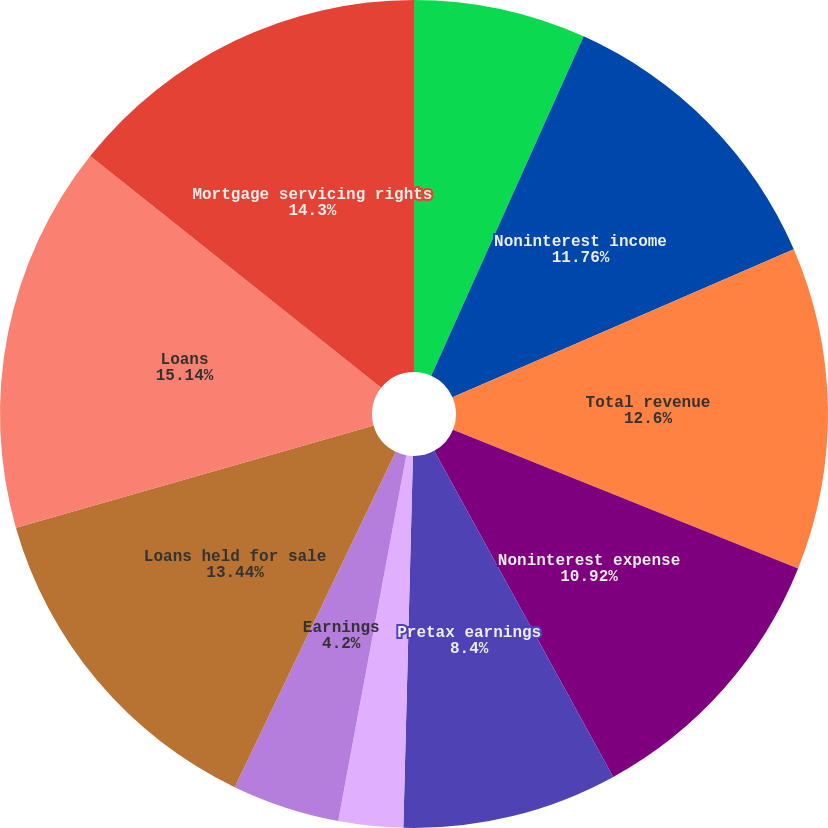<chart> <loc_0><loc_0><loc_500><loc_500><pie_chart><fcel>Net interest income<fcel>Noninterest income<fcel>Total revenue<fcel>Noninterest expense<fcel>Pretax earnings<fcel>Income taxes<fcel>Earnings<fcel>Loans held for sale<fcel>Loans<fcel>Mortgage servicing rights<nl><fcel>6.72%<fcel>11.76%<fcel>12.6%<fcel>10.92%<fcel>8.4%<fcel>2.52%<fcel>4.2%<fcel>13.44%<fcel>15.13%<fcel>14.29%<nl></chart> 